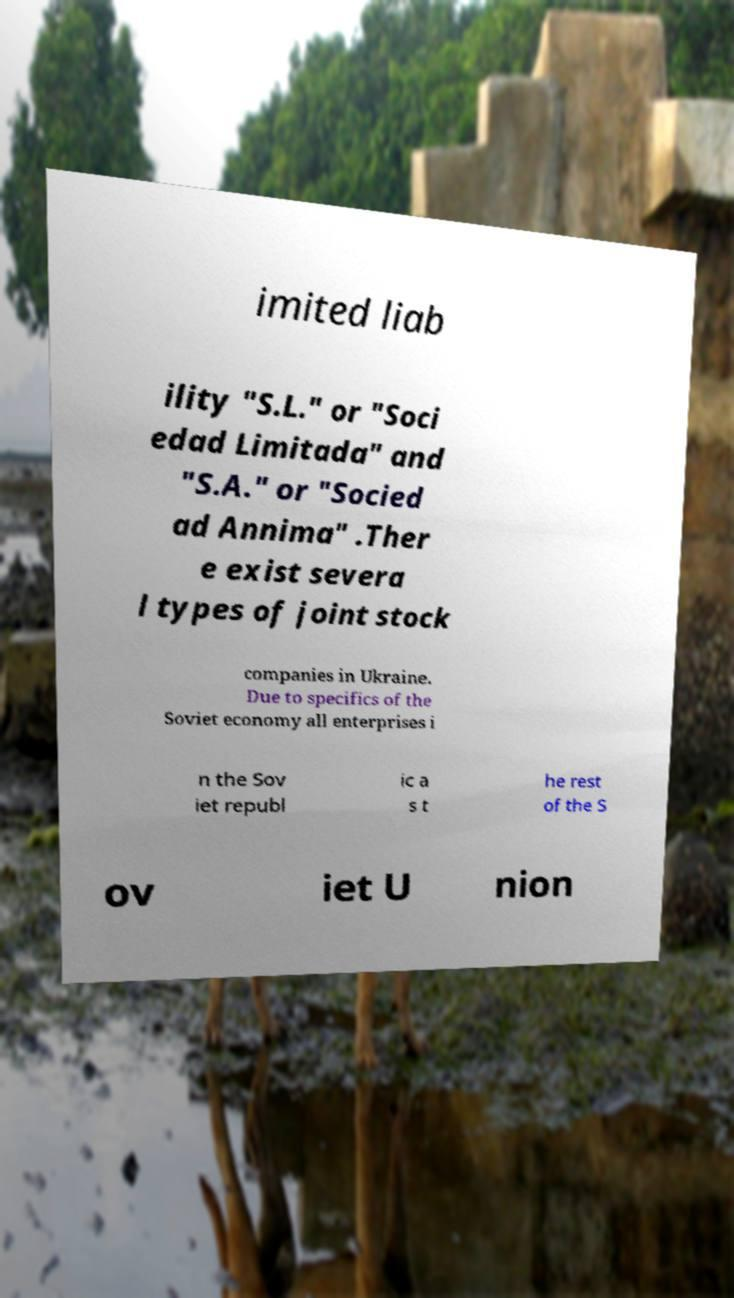Please read and relay the text visible in this image. What does it say? imited liab ility "S.L." or "Soci edad Limitada" and "S.A." or "Socied ad Annima" .Ther e exist severa l types of joint stock companies in Ukraine. Due to specifics of the Soviet economy all enterprises i n the Sov iet republ ic a s t he rest of the S ov iet U nion 